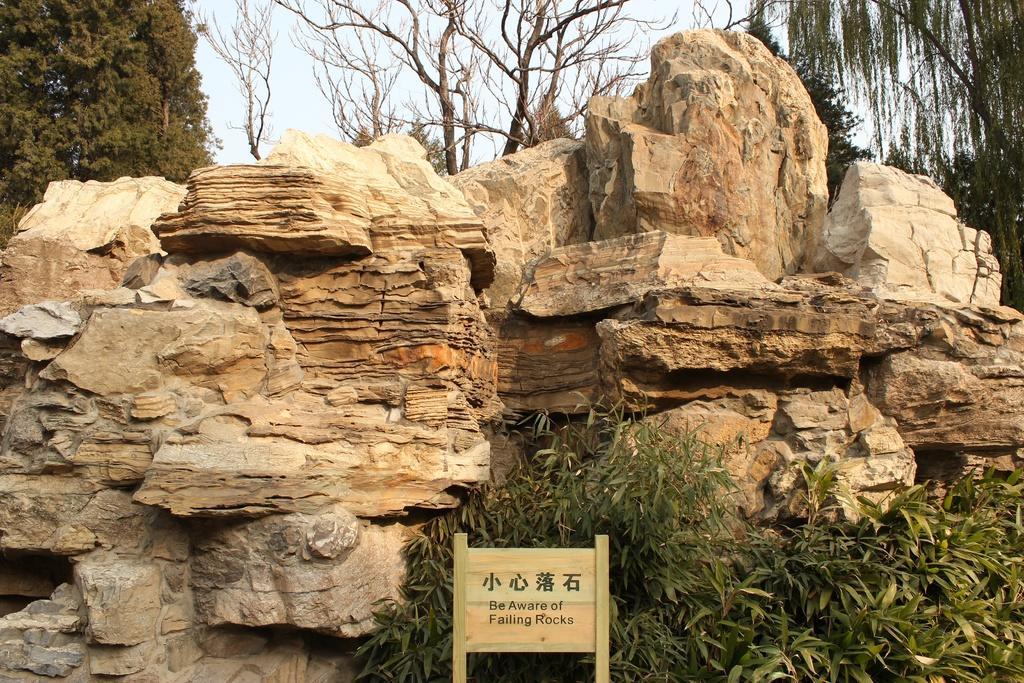In one or two sentences, can you explain what this image depicts? In this picture we observe few rocks and there is a poster on which Be aware of falling rocks is written and in the background we observe trees. 